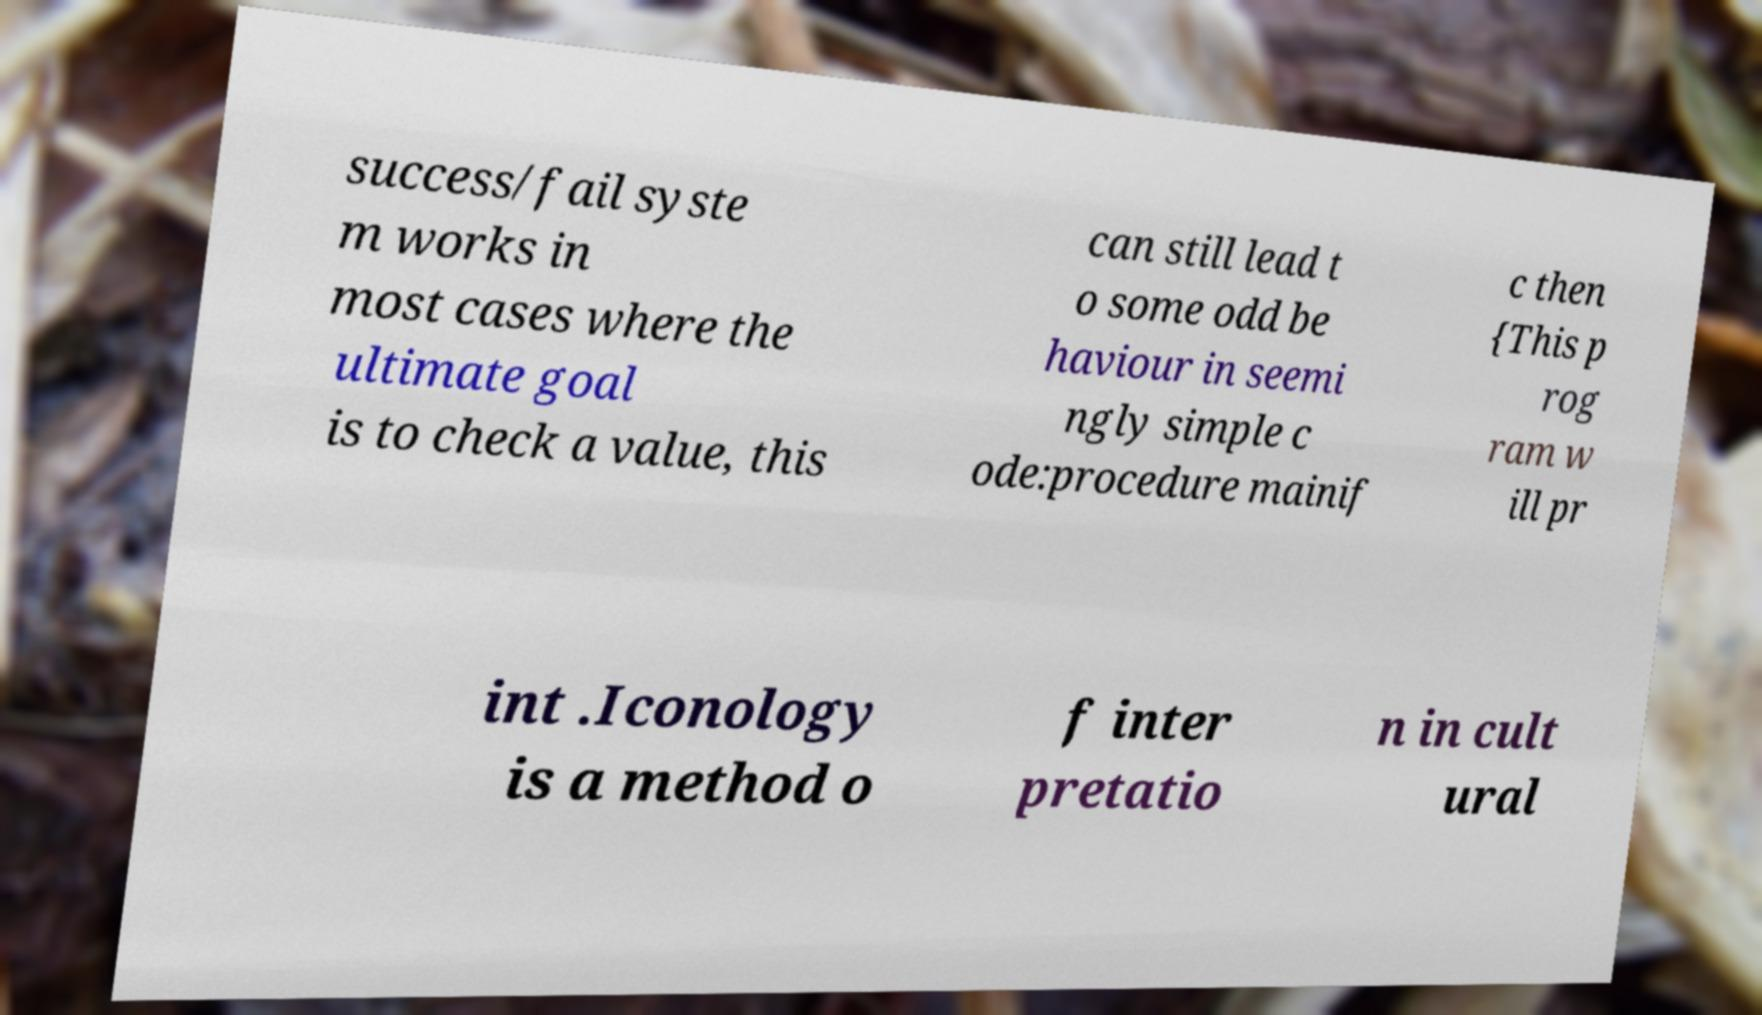Please read and relay the text visible in this image. What does it say? success/fail syste m works in most cases where the ultimate goal is to check a value, this can still lead t o some odd be haviour in seemi ngly simple c ode:procedure mainif c then {This p rog ram w ill pr int .Iconology is a method o f inter pretatio n in cult ural 